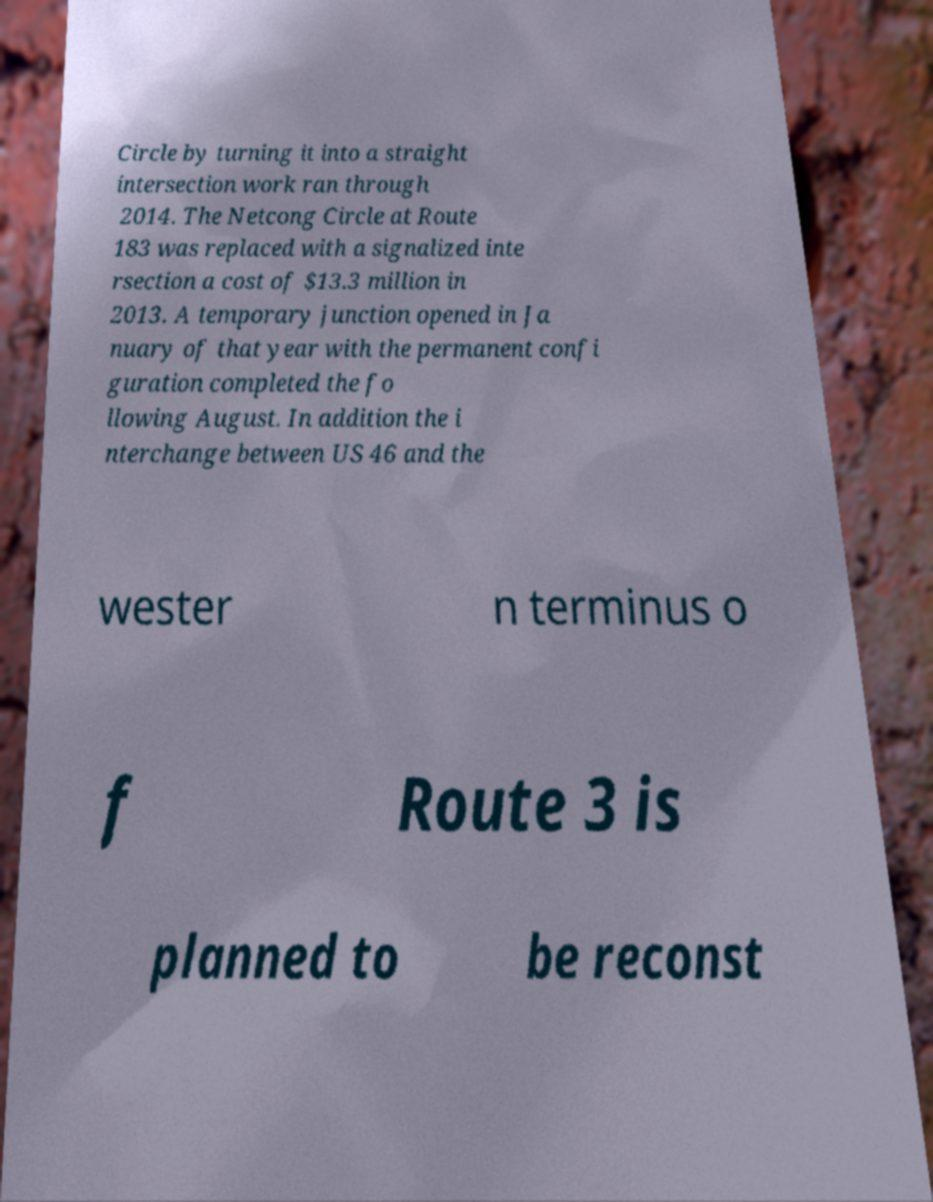What messages or text are displayed in this image? I need them in a readable, typed format. Circle by turning it into a straight intersection work ran through 2014. The Netcong Circle at Route 183 was replaced with a signalized inte rsection a cost of $13.3 million in 2013. A temporary junction opened in Ja nuary of that year with the permanent confi guration completed the fo llowing August. In addition the i nterchange between US 46 and the wester n terminus o f Route 3 is planned to be reconst 